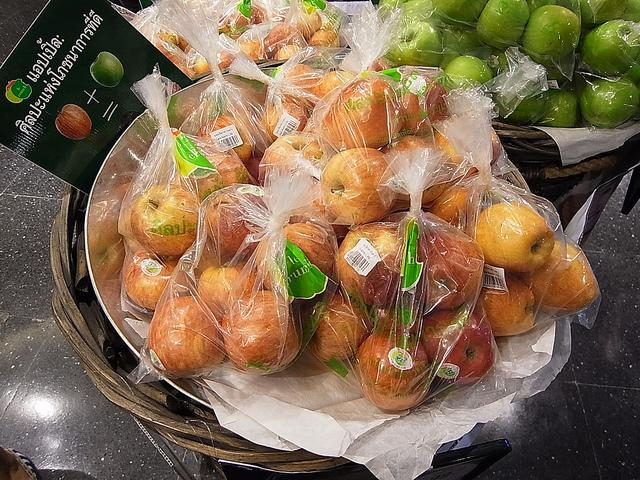What is the condition of these items? Please explain your reasoning. wrapped. Fruit is seen in plastic bags with ties. 